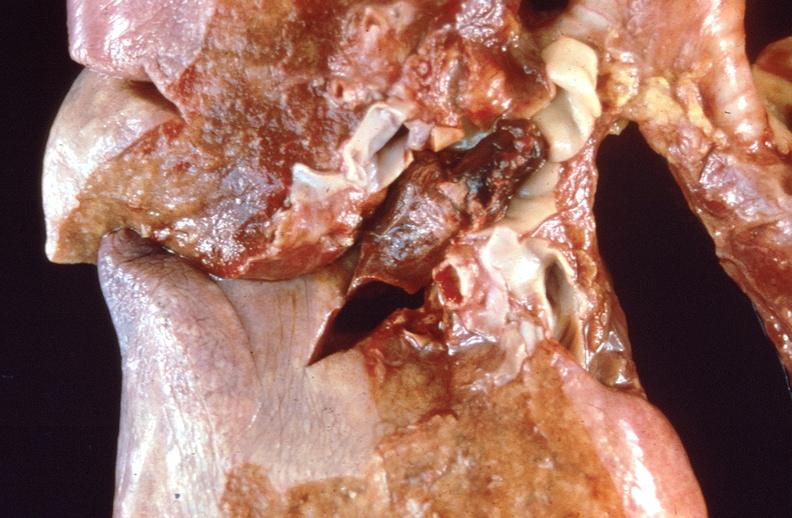what is present?
Answer the question using a single word or phrase. Respiratory 